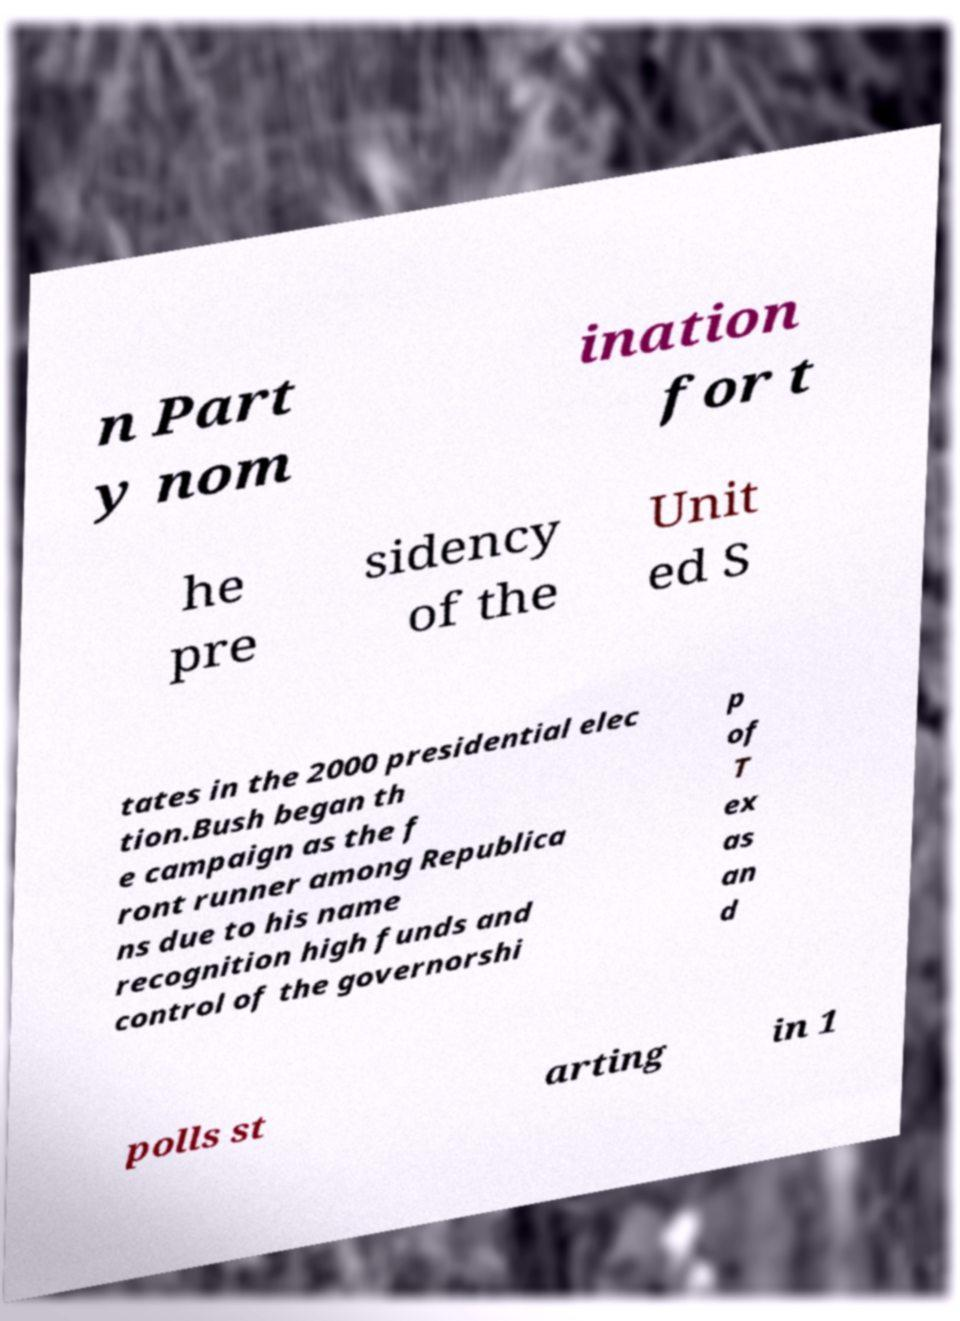For documentation purposes, I need the text within this image transcribed. Could you provide that? n Part y nom ination for t he pre sidency of the Unit ed S tates in the 2000 presidential elec tion.Bush began th e campaign as the f ront runner among Republica ns due to his name recognition high funds and control of the governorshi p of T ex as an d polls st arting in 1 